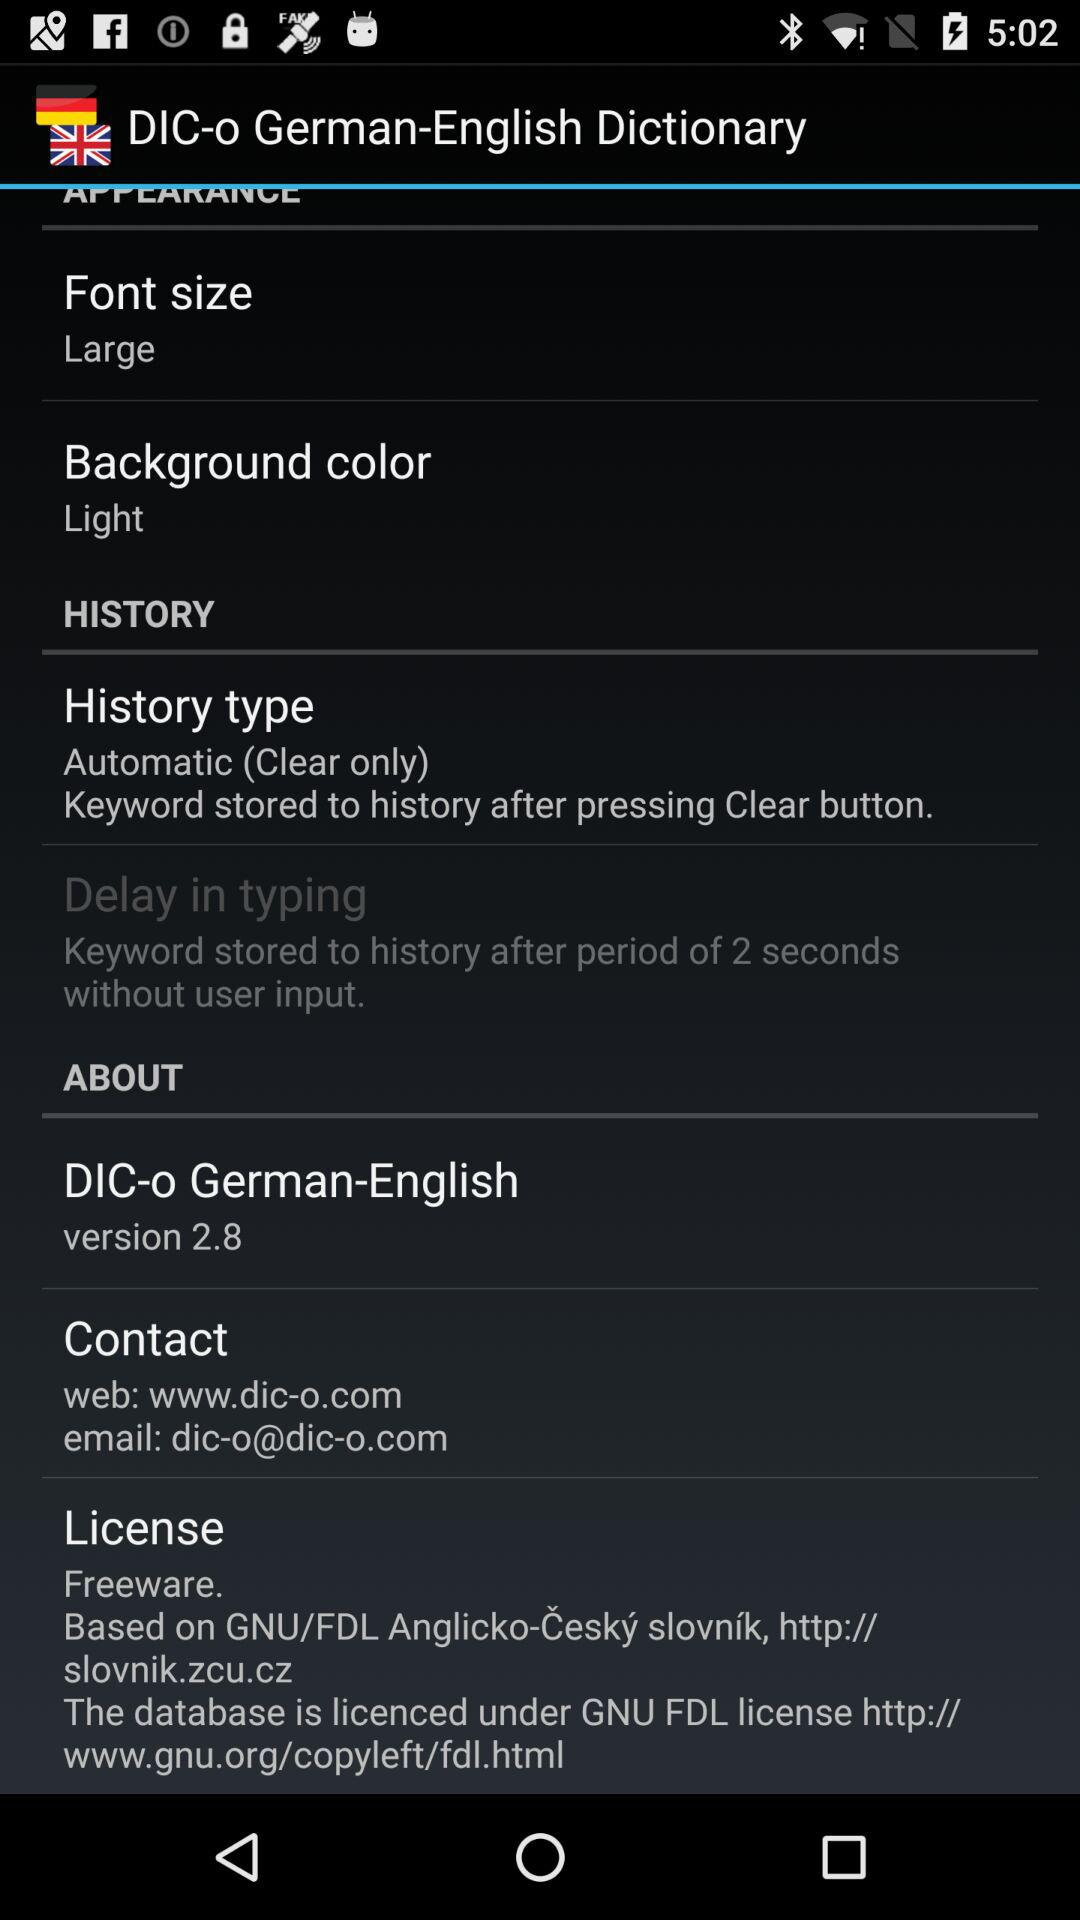What is the website link? The website link is "www.dic-o.com". 